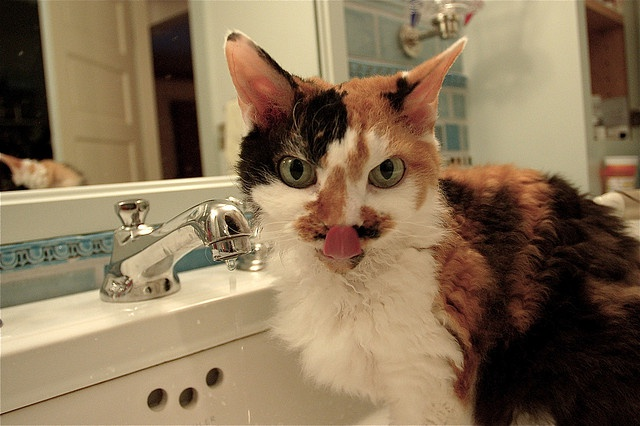Describe the objects in this image and their specific colors. I can see cat in black, tan, and maroon tones and sink in black and tan tones in this image. 